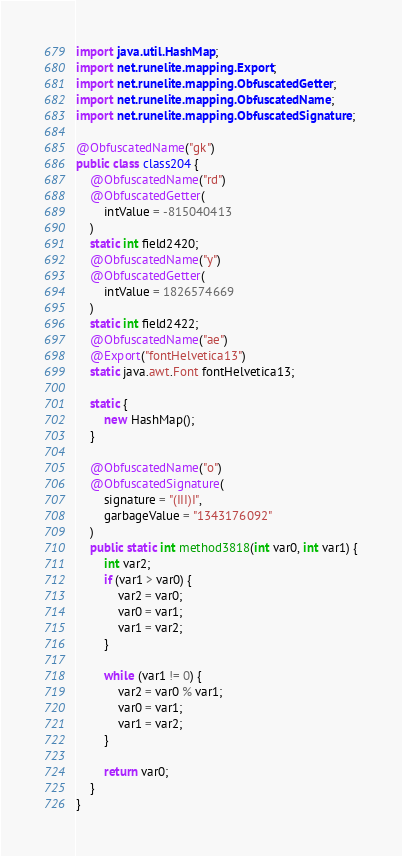<code> <loc_0><loc_0><loc_500><loc_500><_Java_>import java.util.HashMap;
import net.runelite.mapping.Export;
import net.runelite.mapping.ObfuscatedGetter;
import net.runelite.mapping.ObfuscatedName;
import net.runelite.mapping.ObfuscatedSignature;

@ObfuscatedName("gk")
public class class204 {
	@ObfuscatedName("rd")
	@ObfuscatedGetter(
		intValue = -815040413
	)
	static int field2420;
	@ObfuscatedName("y")
	@ObfuscatedGetter(
		intValue = 1826574669
	)
	static int field2422;
	@ObfuscatedName("ae")
	@Export("fontHelvetica13")
	static java.awt.Font fontHelvetica13;

	static {
		new HashMap();
	}

	@ObfuscatedName("o")
	@ObfuscatedSignature(
		signature = "(III)I",
		garbageValue = "1343176092"
	)
	public static int method3818(int var0, int var1) {
		int var2;
		if (var1 > var0) {
			var2 = var0;
			var0 = var1;
			var1 = var2;
		}

		while (var1 != 0) {
			var2 = var0 % var1;
			var0 = var1;
			var1 = var2;
		}

		return var0;
	}
}
</code> 